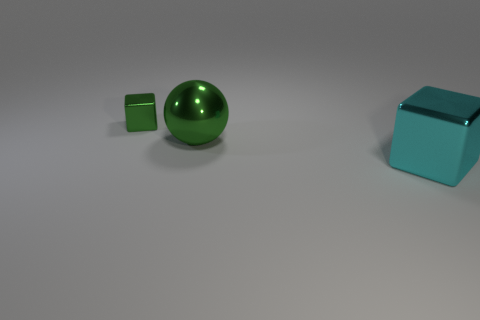Add 2 small shiny blocks. How many objects exist? 5 Subtract all blocks. How many objects are left? 1 Subtract all metallic balls. Subtract all big shiny things. How many objects are left? 0 Add 1 tiny cubes. How many tiny cubes are left? 2 Add 1 small green metallic blocks. How many small green metallic blocks exist? 2 Subtract 0 green cylinders. How many objects are left? 3 